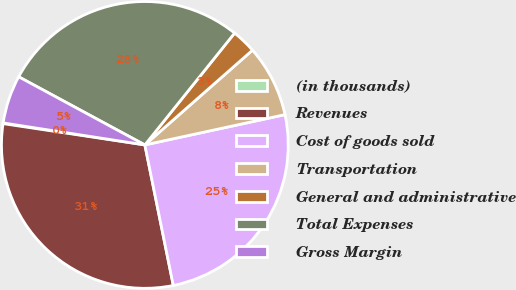Convert chart to OTSL. <chart><loc_0><loc_0><loc_500><loc_500><pie_chart><fcel>(in thousands)<fcel>Revenues<fcel>Cost of goods sold<fcel>Transportation<fcel>General and administrative<fcel>Total Expenses<fcel>Gross Margin<nl><fcel>0.08%<fcel>30.55%<fcel>25.21%<fcel>8.1%<fcel>2.75%<fcel>27.88%<fcel>5.43%<nl></chart> 